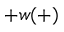<formula> <loc_0><loc_0><loc_500><loc_500>+ w ( + )</formula> 